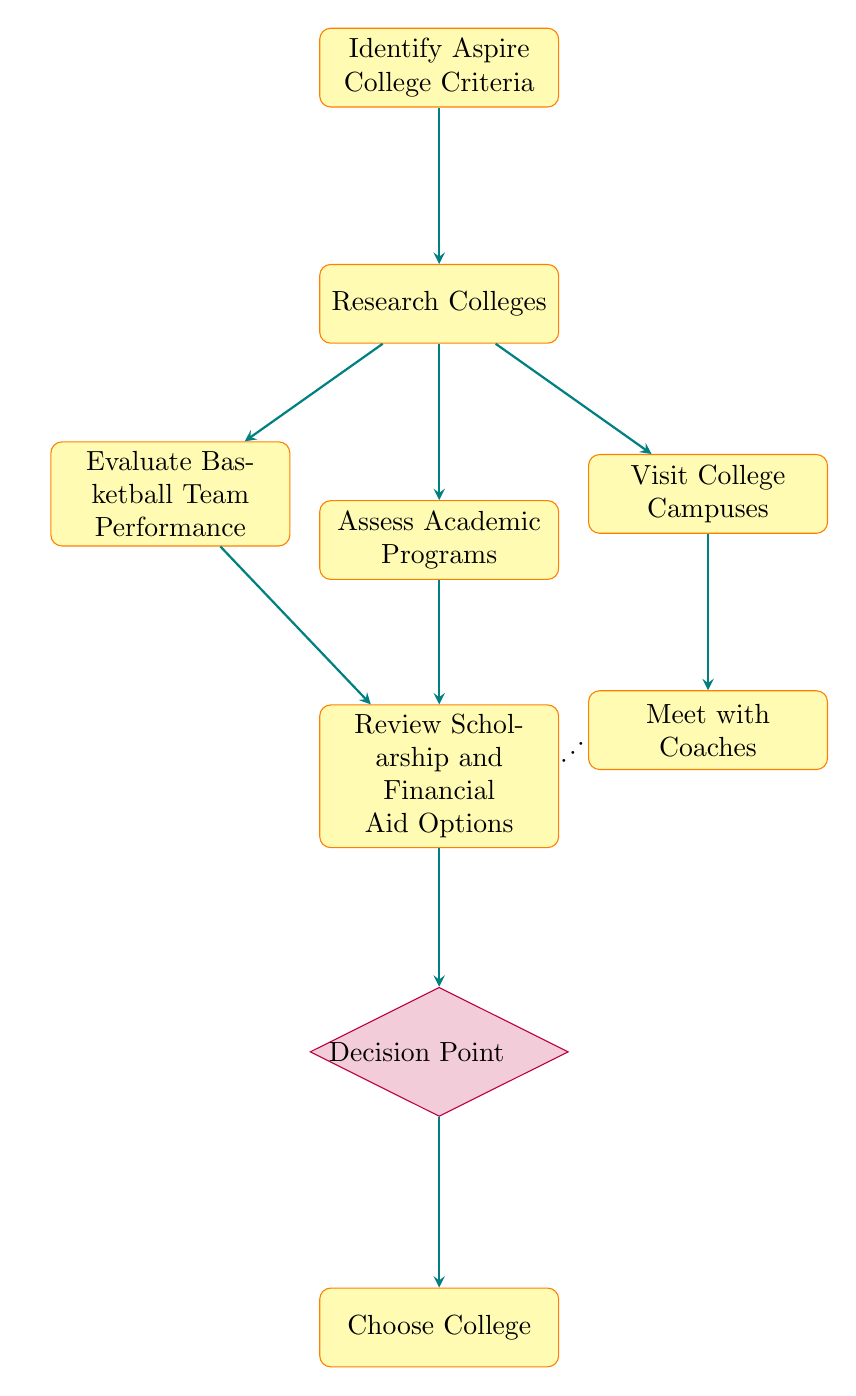What is the first step in the flow chart? The first step, according to the diagram, is "Identify Aspire College Criteria", which initiates the decision-making process related to choosing a college with a strong basketball program.
Answer: Identify Aspire College Criteria How many nodes are there in the flow chart? The flow chart contains a total of 9 nodes, each representing a specific step in the decision-making process for choosing colleges.
Answer: 9 What is the node that follows "Visit College Campuses"? The node that follows "Visit College Campuses" in the flow chart is "Meet with Coaches", indicating the next step after visiting the campuses.
Answer: Meet with Coaches What are the two nodes that lead to "Review Scholarship and Financial Aid Options"? The two nodes leading to "Review Scholarship and Financial Aid Options" are "Evaluate Basketball Team Performance" and "Assess Academic Programs"; both steps assess aspects that influence financial aid options.
Answer: Evaluate Basketball Team Performance, Assess Academic Programs What is the final decision in the flow chart? The final decision in the flow chart is represented by the node "Choose College", which is the outcome after evaluating all previous factors.
Answer: Choose College What is the relationship between "Research Colleges" and the other nodes? "Research Colleges" serves as a central node with direct connections to three other nodes: "Evaluate Basketball Team Performance", "Assess Academic Programs", and "Visit College Campuses", signifying essential steps that follow institution research.
Answer: Central node to three other nodes At which point do you weigh all factors before making a decision? You weigh all factors at the "Decision Point", where various considerations including program strength and financial aid options are assessed before finalizing the choice.
Answer: Decision Point Which well-known coaches are referred to in the "Meet with Coaches" node? The "Meet with Coaches" node refers to notable coaches such as Geno Auriemma, Tara VanDerveer, and Dawn Staley, highlighting the importance of coach interaction.
Answer: Geno Auriemma, Tara VanDerveer, Dawn Staley 